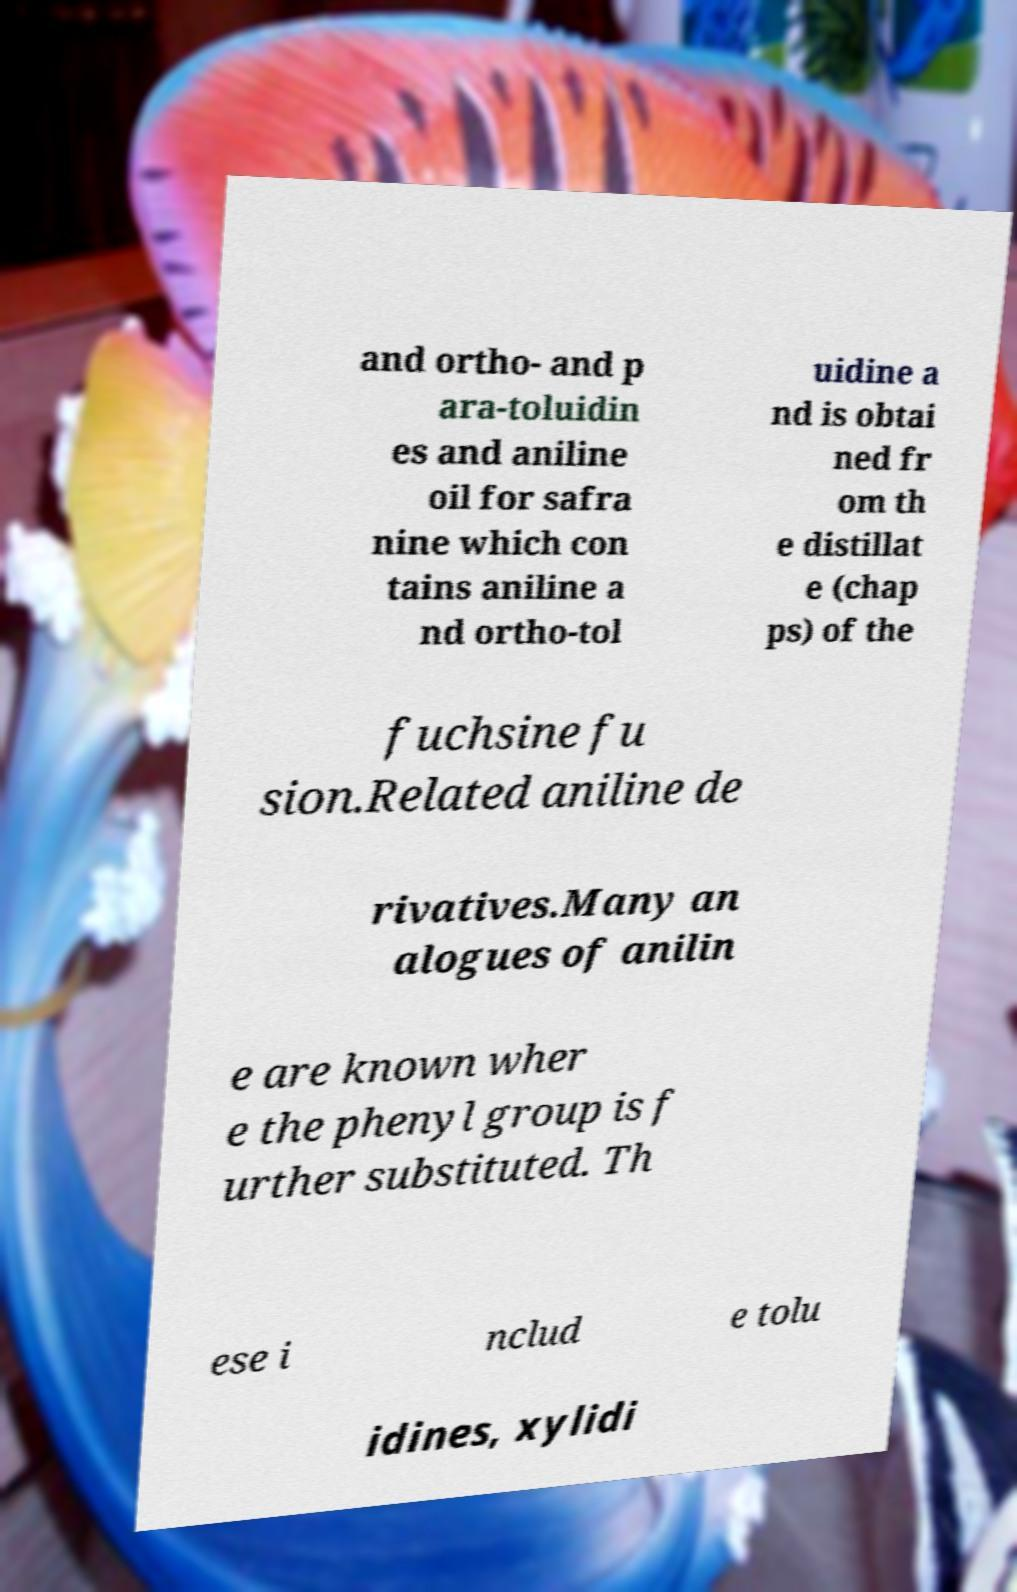Can you accurately transcribe the text from the provided image for me? and ortho- and p ara-toluidin es and aniline oil for safra nine which con tains aniline a nd ortho-tol uidine a nd is obtai ned fr om th e distillat e (chap ps) of the fuchsine fu sion.Related aniline de rivatives.Many an alogues of anilin e are known wher e the phenyl group is f urther substituted. Th ese i nclud e tolu idines, xylidi 